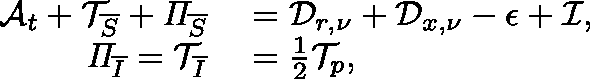Convert formula to latex. <formula><loc_0><loc_0><loc_500><loc_500>\begin{array} { r l } { \mathcal { A } _ { t } + \mathcal { T } _ { \overline { S } } + \Pi _ { \overline { S } } } & = \mathcal { D } _ { r , \nu } + \mathcal { D } _ { x , \nu } - \mathcal { \epsilon } + \mathcal { I } , } \\ { \Pi _ { \overline { I } } = \mathcal { T } _ { \overline { I } } } & = \frac { 1 } { 2 } \mathcal { T } _ { p } , } \end{array}</formula> 